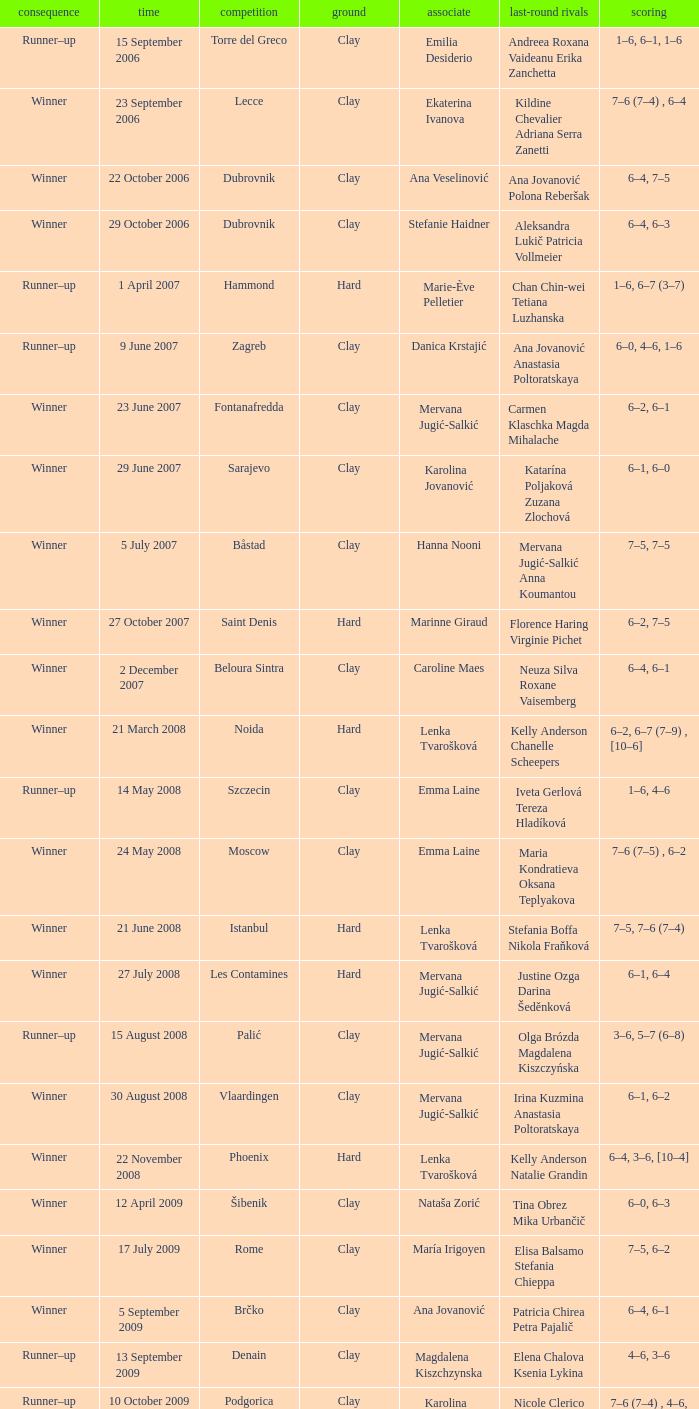Who were the opponents in the final at Noida? Kelly Anderson Chanelle Scheepers. 